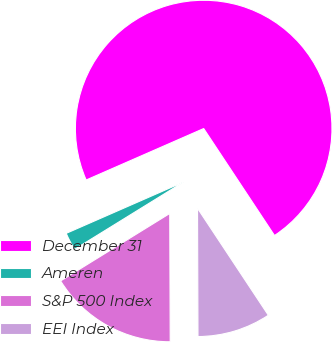<chart> <loc_0><loc_0><loc_500><loc_500><pie_chart><fcel>December 31<fcel>Ameren<fcel>S&P 500 Index<fcel>EEI Index<nl><fcel>72.26%<fcel>2.24%<fcel>16.25%<fcel>9.25%<nl></chart> 